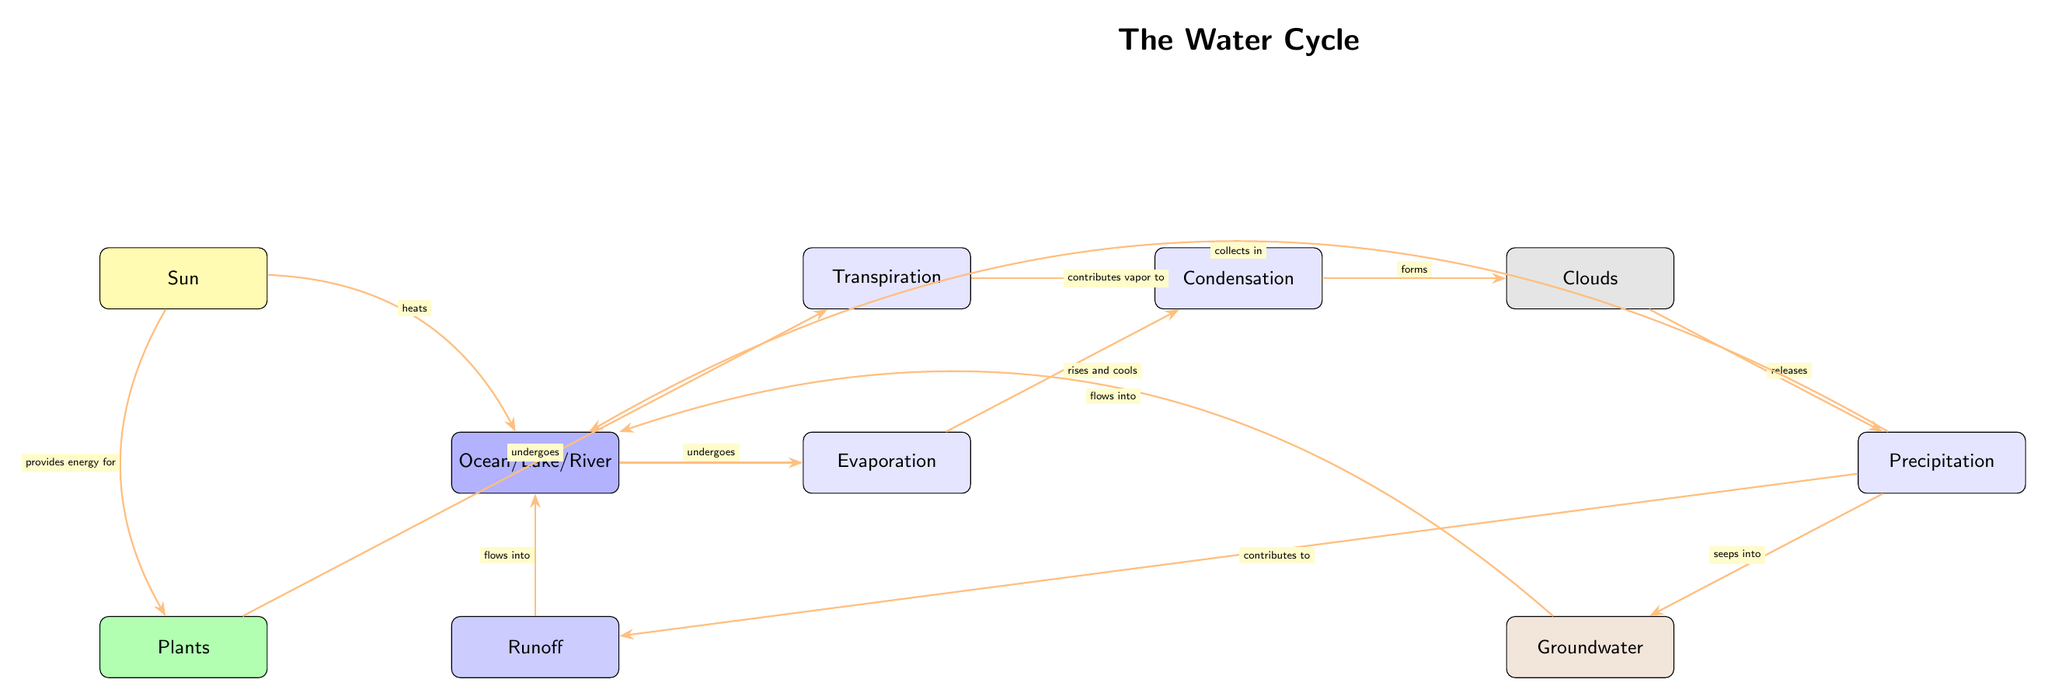What process causes water to rise from the "Ocean/Lake/River"? The diagram indicates that the "Evaporation" process is triggered by the "Sun" which heats the water, leading to its rise into the atmosphere.
Answer: Evaporation What is formed after the "Evaporation" process? According to the diagram, once water evaporates, it rises and cools, resulting in "Condensation."
Answer: Condensation How many main processes are indicated in the water cycle? The diagram displays four key processes: Evaporation, Condensation, Precipitation, and Transpiration. Counting all of these gives a total of four processes.
Answer: 4 What role do "Clouds" play in the water cycle? The diagram shows that "Clouds" are formed through the process of "Condensation" and later lead to the release of water in the form of "Precipitation."
Answer: Release water What happens to water after "Precipitation"? The diagram illustrates that after "Precipitation," water collects back into the "Ocean/Lake/River" and also seeps into the "Groundwater," and contributes to "Runoff."
Answer: Collects in water Which component contributes vapor to the process of "Condensation"? The diagram indicates that "Transpiration," which is associated with "Plants," contributes vapor to the "Condensation" node.
Answer: Transpiration What effect does the "Sun" have on "Plants"? The diagram shows that the "Sun" provides energy for "Plants," suggesting a direct influence that supports their growth and the transpiration process.
Answer: Provides energy for What does the "Precipitation" process contribute to "Runoff"? According to the diagram, the process of "Precipitation" contributes to the "Runoff," which indicates that water flows away from the land after precipitation occurs.
Answer: Contributes to What is the sequence between "Clouds" and "Precipitation"? The diagram demonstrates a clear sequence where "Clouds" release water through the process of "Precipitation," indicating the flow from one to the other.
Answer: Clouds to Precipitation How does water return to the "Groundwater"? The diagram depicts that water from "Precipitation" seeps into the "Groundwater" after it has fallen, indicating a direct flow from precipitation to groundwater.
Answer: Seeps into Groundwater 